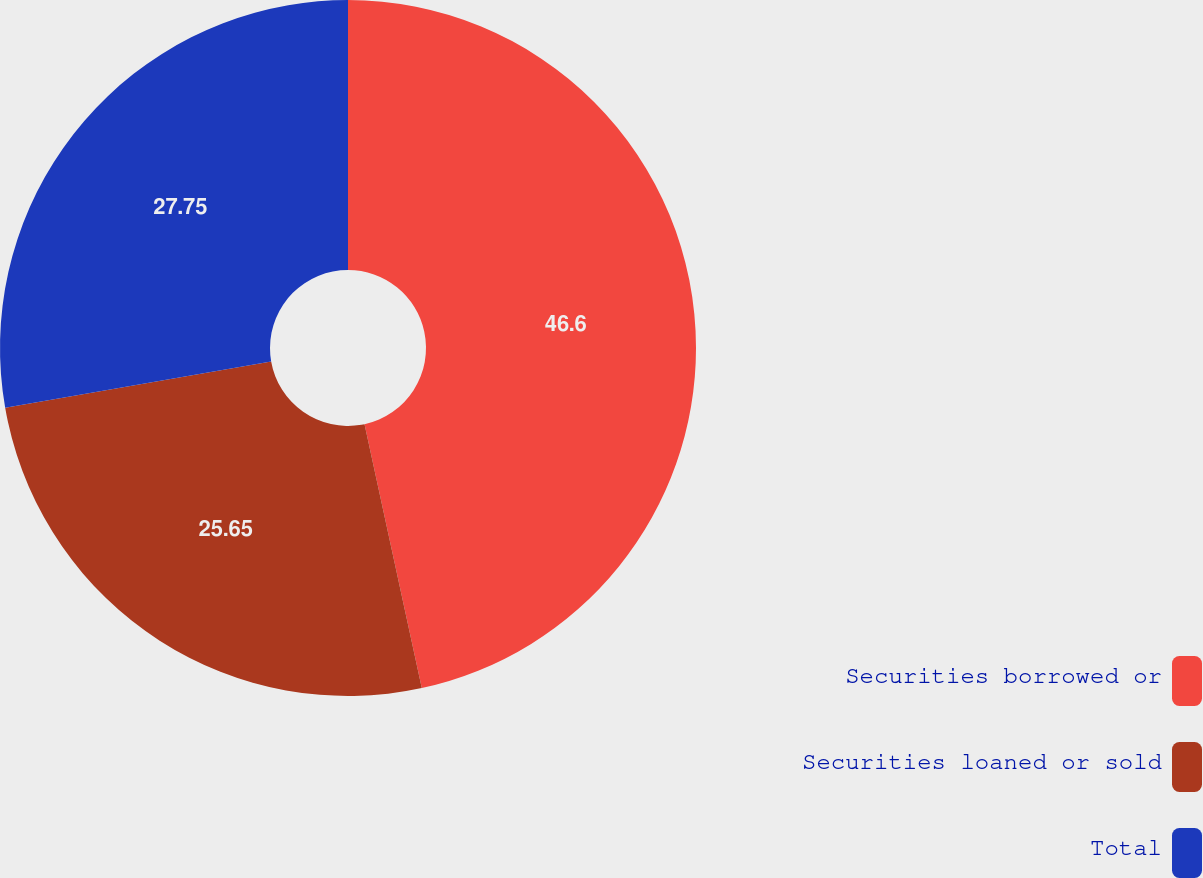Convert chart. <chart><loc_0><loc_0><loc_500><loc_500><pie_chart><fcel>Securities borrowed or<fcel>Securities loaned or sold<fcel>Total<nl><fcel>46.6%<fcel>25.65%<fcel>27.75%<nl></chart> 